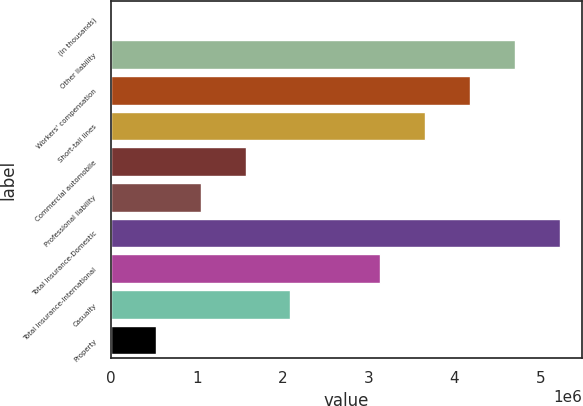Convert chart to OTSL. <chart><loc_0><loc_0><loc_500><loc_500><bar_chart><fcel>(In thousands)<fcel>Other liability<fcel>Workers' compensation<fcel>Short-tail lines<fcel>Commercial automobile<fcel>Professional liability<fcel>Total Insurance-Domestic<fcel>Total Insurance-International<fcel>Casualty<fcel>Property<nl><fcel>2013<fcel>4.70408e+06<fcel>4.18163e+06<fcel>3.65918e+06<fcel>1.56937e+06<fcel>1.04692e+06<fcel>5.22654e+06<fcel>3.13673e+06<fcel>2.09182e+06<fcel>524465<nl></chart> 